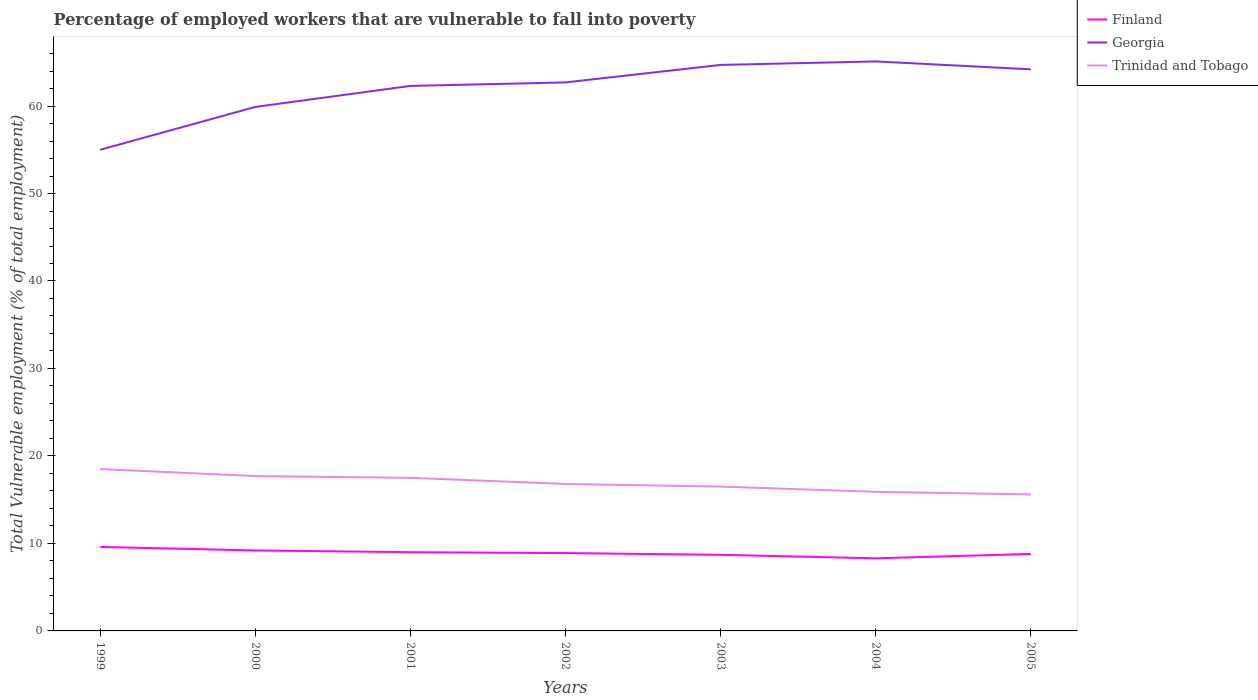How many different coloured lines are there?
Offer a very short reply. 3. Does the line corresponding to Georgia intersect with the line corresponding to Trinidad and Tobago?
Your answer should be very brief. No. Across all years, what is the maximum percentage of employed workers who are vulnerable to fall into poverty in Georgia?
Make the answer very short. 55. In which year was the percentage of employed workers who are vulnerable to fall into poverty in Trinidad and Tobago maximum?
Ensure brevity in your answer.  2005. What is the total percentage of employed workers who are vulnerable to fall into poverty in Trinidad and Tobago in the graph?
Your answer should be very brief. 2.1. What is the difference between the highest and the second highest percentage of employed workers who are vulnerable to fall into poverty in Finland?
Offer a terse response. 1.3. What is the difference between the highest and the lowest percentage of employed workers who are vulnerable to fall into poverty in Trinidad and Tobago?
Offer a very short reply. 3. Is the percentage of employed workers who are vulnerable to fall into poverty in Georgia strictly greater than the percentage of employed workers who are vulnerable to fall into poverty in Finland over the years?
Make the answer very short. No. How many years are there in the graph?
Keep it short and to the point. 7. Where does the legend appear in the graph?
Offer a very short reply. Top right. How many legend labels are there?
Provide a succinct answer. 3. What is the title of the graph?
Provide a short and direct response. Percentage of employed workers that are vulnerable to fall into poverty. Does "Hungary" appear as one of the legend labels in the graph?
Offer a terse response. No. What is the label or title of the Y-axis?
Keep it short and to the point. Total Vulnerable employment (% of total employment). What is the Total Vulnerable employment (% of total employment) of Finland in 1999?
Ensure brevity in your answer.  9.6. What is the Total Vulnerable employment (% of total employment) of Georgia in 1999?
Provide a short and direct response. 55. What is the Total Vulnerable employment (% of total employment) in Trinidad and Tobago in 1999?
Ensure brevity in your answer.  18.5. What is the Total Vulnerable employment (% of total employment) of Finland in 2000?
Offer a very short reply. 9.2. What is the Total Vulnerable employment (% of total employment) of Georgia in 2000?
Offer a very short reply. 59.9. What is the Total Vulnerable employment (% of total employment) of Trinidad and Tobago in 2000?
Offer a very short reply. 17.7. What is the Total Vulnerable employment (% of total employment) of Finland in 2001?
Give a very brief answer. 9. What is the Total Vulnerable employment (% of total employment) of Georgia in 2001?
Offer a very short reply. 62.3. What is the Total Vulnerable employment (% of total employment) in Trinidad and Tobago in 2001?
Your answer should be compact. 17.5. What is the Total Vulnerable employment (% of total employment) in Finland in 2002?
Keep it short and to the point. 8.9. What is the Total Vulnerable employment (% of total employment) of Georgia in 2002?
Ensure brevity in your answer.  62.7. What is the Total Vulnerable employment (% of total employment) in Trinidad and Tobago in 2002?
Provide a short and direct response. 16.8. What is the Total Vulnerable employment (% of total employment) in Finland in 2003?
Your answer should be very brief. 8.7. What is the Total Vulnerable employment (% of total employment) of Georgia in 2003?
Your answer should be very brief. 64.7. What is the Total Vulnerable employment (% of total employment) in Finland in 2004?
Give a very brief answer. 8.3. What is the Total Vulnerable employment (% of total employment) in Georgia in 2004?
Offer a terse response. 65.1. What is the Total Vulnerable employment (% of total employment) in Trinidad and Tobago in 2004?
Give a very brief answer. 15.9. What is the Total Vulnerable employment (% of total employment) of Finland in 2005?
Your response must be concise. 8.8. What is the Total Vulnerable employment (% of total employment) of Georgia in 2005?
Ensure brevity in your answer.  64.2. What is the Total Vulnerable employment (% of total employment) in Trinidad and Tobago in 2005?
Offer a terse response. 15.6. Across all years, what is the maximum Total Vulnerable employment (% of total employment) in Finland?
Your answer should be very brief. 9.6. Across all years, what is the maximum Total Vulnerable employment (% of total employment) in Georgia?
Give a very brief answer. 65.1. Across all years, what is the maximum Total Vulnerable employment (% of total employment) of Trinidad and Tobago?
Your answer should be compact. 18.5. Across all years, what is the minimum Total Vulnerable employment (% of total employment) in Finland?
Make the answer very short. 8.3. Across all years, what is the minimum Total Vulnerable employment (% of total employment) of Georgia?
Your answer should be compact. 55. Across all years, what is the minimum Total Vulnerable employment (% of total employment) of Trinidad and Tobago?
Your response must be concise. 15.6. What is the total Total Vulnerable employment (% of total employment) in Finland in the graph?
Keep it short and to the point. 62.5. What is the total Total Vulnerable employment (% of total employment) of Georgia in the graph?
Make the answer very short. 433.9. What is the total Total Vulnerable employment (% of total employment) in Trinidad and Tobago in the graph?
Ensure brevity in your answer.  118.5. What is the difference between the Total Vulnerable employment (% of total employment) of Georgia in 1999 and that in 2000?
Ensure brevity in your answer.  -4.9. What is the difference between the Total Vulnerable employment (% of total employment) of Georgia in 1999 and that in 2001?
Make the answer very short. -7.3. What is the difference between the Total Vulnerable employment (% of total employment) of Trinidad and Tobago in 1999 and that in 2001?
Provide a succinct answer. 1. What is the difference between the Total Vulnerable employment (% of total employment) in Finland in 1999 and that in 2002?
Your response must be concise. 0.7. What is the difference between the Total Vulnerable employment (% of total employment) in Georgia in 1999 and that in 2002?
Offer a very short reply. -7.7. What is the difference between the Total Vulnerable employment (% of total employment) in Finland in 1999 and that in 2003?
Your answer should be compact. 0.9. What is the difference between the Total Vulnerable employment (% of total employment) of Georgia in 1999 and that in 2003?
Offer a terse response. -9.7. What is the difference between the Total Vulnerable employment (% of total employment) in Finland in 1999 and that in 2004?
Make the answer very short. 1.3. What is the difference between the Total Vulnerable employment (% of total employment) in Finland in 1999 and that in 2005?
Make the answer very short. 0.8. What is the difference between the Total Vulnerable employment (% of total employment) of Georgia in 1999 and that in 2005?
Your answer should be very brief. -9.2. What is the difference between the Total Vulnerable employment (% of total employment) of Finland in 2000 and that in 2001?
Ensure brevity in your answer.  0.2. What is the difference between the Total Vulnerable employment (% of total employment) in Trinidad and Tobago in 2000 and that in 2001?
Ensure brevity in your answer.  0.2. What is the difference between the Total Vulnerable employment (% of total employment) of Finland in 2000 and that in 2002?
Your answer should be very brief. 0.3. What is the difference between the Total Vulnerable employment (% of total employment) in Georgia in 2000 and that in 2002?
Provide a succinct answer. -2.8. What is the difference between the Total Vulnerable employment (% of total employment) in Georgia in 2000 and that in 2003?
Give a very brief answer. -4.8. What is the difference between the Total Vulnerable employment (% of total employment) in Finland in 2000 and that in 2004?
Keep it short and to the point. 0.9. What is the difference between the Total Vulnerable employment (% of total employment) in Georgia in 2000 and that in 2004?
Keep it short and to the point. -5.2. What is the difference between the Total Vulnerable employment (% of total employment) of Trinidad and Tobago in 2000 and that in 2005?
Your answer should be compact. 2.1. What is the difference between the Total Vulnerable employment (% of total employment) of Finland in 2001 and that in 2002?
Keep it short and to the point. 0.1. What is the difference between the Total Vulnerable employment (% of total employment) of Georgia in 2001 and that in 2002?
Your response must be concise. -0.4. What is the difference between the Total Vulnerable employment (% of total employment) in Finland in 2001 and that in 2004?
Give a very brief answer. 0.7. What is the difference between the Total Vulnerable employment (% of total employment) in Georgia in 2001 and that in 2004?
Ensure brevity in your answer.  -2.8. What is the difference between the Total Vulnerable employment (% of total employment) in Trinidad and Tobago in 2001 and that in 2004?
Give a very brief answer. 1.6. What is the difference between the Total Vulnerable employment (% of total employment) in Georgia in 2001 and that in 2005?
Make the answer very short. -1.9. What is the difference between the Total Vulnerable employment (% of total employment) of Finland in 2002 and that in 2003?
Make the answer very short. 0.2. What is the difference between the Total Vulnerable employment (% of total employment) in Georgia in 2002 and that in 2003?
Your response must be concise. -2. What is the difference between the Total Vulnerable employment (% of total employment) in Georgia in 2002 and that in 2004?
Give a very brief answer. -2.4. What is the difference between the Total Vulnerable employment (% of total employment) in Finland in 2002 and that in 2005?
Offer a very short reply. 0.1. What is the difference between the Total Vulnerable employment (% of total employment) in Trinidad and Tobago in 2002 and that in 2005?
Keep it short and to the point. 1.2. What is the difference between the Total Vulnerable employment (% of total employment) of Finland in 2003 and that in 2004?
Offer a very short reply. 0.4. What is the difference between the Total Vulnerable employment (% of total employment) of Georgia in 2003 and that in 2004?
Your answer should be compact. -0.4. What is the difference between the Total Vulnerable employment (% of total employment) of Finland in 2004 and that in 2005?
Offer a terse response. -0.5. What is the difference between the Total Vulnerable employment (% of total employment) of Finland in 1999 and the Total Vulnerable employment (% of total employment) of Georgia in 2000?
Offer a terse response. -50.3. What is the difference between the Total Vulnerable employment (% of total employment) of Georgia in 1999 and the Total Vulnerable employment (% of total employment) of Trinidad and Tobago in 2000?
Give a very brief answer. 37.3. What is the difference between the Total Vulnerable employment (% of total employment) in Finland in 1999 and the Total Vulnerable employment (% of total employment) in Georgia in 2001?
Keep it short and to the point. -52.7. What is the difference between the Total Vulnerable employment (% of total employment) in Georgia in 1999 and the Total Vulnerable employment (% of total employment) in Trinidad and Tobago in 2001?
Your response must be concise. 37.5. What is the difference between the Total Vulnerable employment (% of total employment) of Finland in 1999 and the Total Vulnerable employment (% of total employment) of Georgia in 2002?
Your answer should be very brief. -53.1. What is the difference between the Total Vulnerable employment (% of total employment) in Finland in 1999 and the Total Vulnerable employment (% of total employment) in Trinidad and Tobago in 2002?
Your answer should be very brief. -7.2. What is the difference between the Total Vulnerable employment (% of total employment) of Georgia in 1999 and the Total Vulnerable employment (% of total employment) of Trinidad and Tobago in 2002?
Your answer should be compact. 38.2. What is the difference between the Total Vulnerable employment (% of total employment) in Finland in 1999 and the Total Vulnerable employment (% of total employment) in Georgia in 2003?
Offer a very short reply. -55.1. What is the difference between the Total Vulnerable employment (% of total employment) in Finland in 1999 and the Total Vulnerable employment (% of total employment) in Trinidad and Tobago in 2003?
Give a very brief answer. -6.9. What is the difference between the Total Vulnerable employment (% of total employment) of Georgia in 1999 and the Total Vulnerable employment (% of total employment) of Trinidad and Tobago in 2003?
Offer a very short reply. 38.5. What is the difference between the Total Vulnerable employment (% of total employment) in Finland in 1999 and the Total Vulnerable employment (% of total employment) in Georgia in 2004?
Make the answer very short. -55.5. What is the difference between the Total Vulnerable employment (% of total employment) in Georgia in 1999 and the Total Vulnerable employment (% of total employment) in Trinidad and Tobago in 2004?
Keep it short and to the point. 39.1. What is the difference between the Total Vulnerable employment (% of total employment) of Finland in 1999 and the Total Vulnerable employment (% of total employment) of Georgia in 2005?
Provide a short and direct response. -54.6. What is the difference between the Total Vulnerable employment (% of total employment) in Georgia in 1999 and the Total Vulnerable employment (% of total employment) in Trinidad and Tobago in 2005?
Provide a short and direct response. 39.4. What is the difference between the Total Vulnerable employment (% of total employment) in Finland in 2000 and the Total Vulnerable employment (% of total employment) in Georgia in 2001?
Ensure brevity in your answer.  -53.1. What is the difference between the Total Vulnerable employment (% of total employment) in Georgia in 2000 and the Total Vulnerable employment (% of total employment) in Trinidad and Tobago in 2001?
Offer a terse response. 42.4. What is the difference between the Total Vulnerable employment (% of total employment) of Finland in 2000 and the Total Vulnerable employment (% of total employment) of Georgia in 2002?
Your answer should be very brief. -53.5. What is the difference between the Total Vulnerable employment (% of total employment) in Georgia in 2000 and the Total Vulnerable employment (% of total employment) in Trinidad and Tobago in 2002?
Your answer should be very brief. 43.1. What is the difference between the Total Vulnerable employment (% of total employment) in Finland in 2000 and the Total Vulnerable employment (% of total employment) in Georgia in 2003?
Provide a short and direct response. -55.5. What is the difference between the Total Vulnerable employment (% of total employment) of Georgia in 2000 and the Total Vulnerable employment (% of total employment) of Trinidad and Tobago in 2003?
Give a very brief answer. 43.4. What is the difference between the Total Vulnerable employment (% of total employment) in Finland in 2000 and the Total Vulnerable employment (% of total employment) in Georgia in 2004?
Your answer should be compact. -55.9. What is the difference between the Total Vulnerable employment (% of total employment) of Finland in 2000 and the Total Vulnerable employment (% of total employment) of Trinidad and Tobago in 2004?
Ensure brevity in your answer.  -6.7. What is the difference between the Total Vulnerable employment (% of total employment) in Finland in 2000 and the Total Vulnerable employment (% of total employment) in Georgia in 2005?
Your answer should be very brief. -55. What is the difference between the Total Vulnerable employment (% of total employment) in Georgia in 2000 and the Total Vulnerable employment (% of total employment) in Trinidad and Tobago in 2005?
Your answer should be very brief. 44.3. What is the difference between the Total Vulnerable employment (% of total employment) of Finland in 2001 and the Total Vulnerable employment (% of total employment) of Georgia in 2002?
Keep it short and to the point. -53.7. What is the difference between the Total Vulnerable employment (% of total employment) in Georgia in 2001 and the Total Vulnerable employment (% of total employment) in Trinidad and Tobago in 2002?
Offer a very short reply. 45.5. What is the difference between the Total Vulnerable employment (% of total employment) in Finland in 2001 and the Total Vulnerable employment (% of total employment) in Georgia in 2003?
Keep it short and to the point. -55.7. What is the difference between the Total Vulnerable employment (% of total employment) in Finland in 2001 and the Total Vulnerable employment (% of total employment) in Trinidad and Tobago in 2003?
Your answer should be compact. -7.5. What is the difference between the Total Vulnerable employment (% of total employment) of Georgia in 2001 and the Total Vulnerable employment (% of total employment) of Trinidad and Tobago in 2003?
Offer a very short reply. 45.8. What is the difference between the Total Vulnerable employment (% of total employment) of Finland in 2001 and the Total Vulnerable employment (% of total employment) of Georgia in 2004?
Keep it short and to the point. -56.1. What is the difference between the Total Vulnerable employment (% of total employment) in Georgia in 2001 and the Total Vulnerable employment (% of total employment) in Trinidad and Tobago in 2004?
Offer a very short reply. 46.4. What is the difference between the Total Vulnerable employment (% of total employment) of Finland in 2001 and the Total Vulnerable employment (% of total employment) of Georgia in 2005?
Your answer should be very brief. -55.2. What is the difference between the Total Vulnerable employment (% of total employment) in Georgia in 2001 and the Total Vulnerable employment (% of total employment) in Trinidad and Tobago in 2005?
Provide a succinct answer. 46.7. What is the difference between the Total Vulnerable employment (% of total employment) in Finland in 2002 and the Total Vulnerable employment (% of total employment) in Georgia in 2003?
Provide a succinct answer. -55.8. What is the difference between the Total Vulnerable employment (% of total employment) of Georgia in 2002 and the Total Vulnerable employment (% of total employment) of Trinidad and Tobago in 2003?
Your response must be concise. 46.2. What is the difference between the Total Vulnerable employment (% of total employment) in Finland in 2002 and the Total Vulnerable employment (% of total employment) in Georgia in 2004?
Your response must be concise. -56.2. What is the difference between the Total Vulnerable employment (% of total employment) in Finland in 2002 and the Total Vulnerable employment (% of total employment) in Trinidad and Tobago in 2004?
Offer a terse response. -7. What is the difference between the Total Vulnerable employment (% of total employment) of Georgia in 2002 and the Total Vulnerable employment (% of total employment) of Trinidad and Tobago in 2004?
Offer a terse response. 46.8. What is the difference between the Total Vulnerable employment (% of total employment) of Finland in 2002 and the Total Vulnerable employment (% of total employment) of Georgia in 2005?
Provide a succinct answer. -55.3. What is the difference between the Total Vulnerable employment (% of total employment) of Georgia in 2002 and the Total Vulnerable employment (% of total employment) of Trinidad and Tobago in 2005?
Keep it short and to the point. 47.1. What is the difference between the Total Vulnerable employment (% of total employment) of Finland in 2003 and the Total Vulnerable employment (% of total employment) of Georgia in 2004?
Provide a succinct answer. -56.4. What is the difference between the Total Vulnerable employment (% of total employment) in Georgia in 2003 and the Total Vulnerable employment (% of total employment) in Trinidad and Tobago in 2004?
Ensure brevity in your answer.  48.8. What is the difference between the Total Vulnerable employment (% of total employment) in Finland in 2003 and the Total Vulnerable employment (% of total employment) in Georgia in 2005?
Provide a short and direct response. -55.5. What is the difference between the Total Vulnerable employment (% of total employment) of Georgia in 2003 and the Total Vulnerable employment (% of total employment) of Trinidad and Tobago in 2005?
Ensure brevity in your answer.  49.1. What is the difference between the Total Vulnerable employment (% of total employment) in Finland in 2004 and the Total Vulnerable employment (% of total employment) in Georgia in 2005?
Make the answer very short. -55.9. What is the difference between the Total Vulnerable employment (% of total employment) of Finland in 2004 and the Total Vulnerable employment (% of total employment) of Trinidad and Tobago in 2005?
Ensure brevity in your answer.  -7.3. What is the difference between the Total Vulnerable employment (% of total employment) in Georgia in 2004 and the Total Vulnerable employment (% of total employment) in Trinidad and Tobago in 2005?
Make the answer very short. 49.5. What is the average Total Vulnerable employment (% of total employment) of Finland per year?
Provide a short and direct response. 8.93. What is the average Total Vulnerable employment (% of total employment) in Georgia per year?
Provide a short and direct response. 61.99. What is the average Total Vulnerable employment (% of total employment) of Trinidad and Tobago per year?
Provide a short and direct response. 16.93. In the year 1999, what is the difference between the Total Vulnerable employment (% of total employment) in Finland and Total Vulnerable employment (% of total employment) in Georgia?
Your answer should be compact. -45.4. In the year 1999, what is the difference between the Total Vulnerable employment (% of total employment) of Georgia and Total Vulnerable employment (% of total employment) of Trinidad and Tobago?
Your answer should be compact. 36.5. In the year 2000, what is the difference between the Total Vulnerable employment (% of total employment) of Finland and Total Vulnerable employment (% of total employment) of Georgia?
Ensure brevity in your answer.  -50.7. In the year 2000, what is the difference between the Total Vulnerable employment (% of total employment) in Georgia and Total Vulnerable employment (% of total employment) in Trinidad and Tobago?
Ensure brevity in your answer.  42.2. In the year 2001, what is the difference between the Total Vulnerable employment (% of total employment) of Finland and Total Vulnerable employment (% of total employment) of Georgia?
Your answer should be compact. -53.3. In the year 2001, what is the difference between the Total Vulnerable employment (% of total employment) in Georgia and Total Vulnerable employment (% of total employment) in Trinidad and Tobago?
Your answer should be compact. 44.8. In the year 2002, what is the difference between the Total Vulnerable employment (% of total employment) in Finland and Total Vulnerable employment (% of total employment) in Georgia?
Provide a succinct answer. -53.8. In the year 2002, what is the difference between the Total Vulnerable employment (% of total employment) in Georgia and Total Vulnerable employment (% of total employment) in Trinidad and Tobago?
Provide a succinct answer. 45.9. In the year 2003, what is the difference between the Total Vulnerable employment (% of total employment) in Finland and Total Vulnerable employment (% of total employment) in Georgia?
Give a very brief answer. -56. In the year 2003, what is the difference between the Total Vulnerable employment (% of total employment) in Finland and Total Vulnerable employment (% of total employment) in Trinidad and Tobago?
Keep it short and to the point. -7.8. In the year 2003, what is the difference between the Total Vulnerable employment (% of total employment) in Georgia and Total Vulnerable employment (% of total employment) in Trinidad and Tobago?
Ensure brevity in your answer.  48.2. In the year 2004, what is the difference between the Total Vulnerable employment (% of total employment) of Finland and Total Vulnerable employment (% of total employment) of Georgia?
Offer a very short reply. -56.8. In the year 2004, what is the difference between the Total Vulnerable employment (% of total employment) in Georgia and Total Vulnerable employment (% of total employment) in Trinidad and Tobago?
Offer a terse response. 49.2. In the year 2005, what is the difference between the Total Vulnerable employment (% of total employment) in Finland and Total Vulnerable employment (% of total employment) in Georgia?
Give a very brief answer. -55.4. In the year 2005, what is the difference between the Total Vulnerable employment (% of total employment) in Finland and Total Vulnerable employment (% of total employment) in Trinidad and Tobago?
Give a very brief answer. -6.8. In the year 2005, what is the difference between the Total Vulnerable employment (% of total employment) in Georgia and Total Vulnerable employment (% of total employment) in Trinidad and Tobago?
Ensure brevity in your answer.  48.6. What is the ratio of the Total Vulnerable employment (% of total employment) in Finland in 1999 to that in 2000?
Provide a succinct answer. 1.04. What is the ratio of the Total Vulnerable employment (% of total employment) in Georgia in 1999 to that in 2000?
Provide a succinct answer. 0.92. What is the ratio of the Total Vulnerable employment (% of total employment) in Trinidad and Tobago in 1999 to that in 2000?
Offer a very short reply. 1.05. What is the ratio of the Total Vulnerable employment (% of total employment) of Finland in 1999 to that in 2001?
Offer a terse response. 1.07. What is the ratio of the Total Vulnerable employment (% of total employment) of Georgia in 1999 to that in 2001?
Ensure brevity in your answer.  0.88. What is the ratio of the Total Vulnerable employment (% of total employment) in Trinidad and Tobago in 1999 to that in 2001?
Offer a terse response. 1.06. What is the ratio of the Total Vulnerable employment (% of total employment) in Finland in 1999 to that in 2002?
Provide a short and direct response. 1.08. What is the ratio of the Total Vulnerable employment (% of total employment) in Georgia in 1999 to that in 2002?
Your response must be concise. 0.88. What is the ratio of the Total Vulnerable employment (% of total employment) in Trinidad and Tobago in 1999 to that in 2002?
Provide a succinct answer. 1.1. What is the ratio of the Total Vulnerable employment (% of total employment) of Finland in 1999 to that in 2003?
Give a very brief answer. 1.1. What is the ratio of the Total Vulnerable employment (% of total employment) in Georgia in 1999 to that in 2003?
Give a very brief answer. 0.85. What is the ratio of the Total Vulnerable employment (% of total employment) in Trinidad and Tobago in 1999 to that in 2003?
Your answer should be very brief. 1.12. What is the ratio of the Total Vulnerable employment (% of total employment) in Finland in 1999 to that in 2004?
Provide a succinct answer. 1.16. What is the ratio of the Total Vulnerable employment (% of total employment) in Georgia in 1999 to that in 2004?
Provide a short and direct response. 0.84. What is the ratio of the Total Vulnerable employment (% of total employment) in Trinidad and Tobago in 1999 to that in 2004?
Keep it short and to the point. 1.16. What is the ratio of the Total Vulnerable employment (% of total employment) of Finland in 1999 to that in 2005?
Provide a short and direct response. 1.09. What is the ratio of the Total Vulnerable employment (% of total employment) in Georgia in 1999 to that in 2005?
Your answer should be very brief. 0.86. What is the ratio of the Total Vulnerable employment (% of total employment) in Trinidad and Tobago in 1999 to that in 2005?
Your response must be concise. 1.19. What is the ratio of the Total Vulnerable employment (% of total employment) of Finland in 2000 to that in 2001?
Provide a succinct answer. 1.02. What is the ratio of the Total Vulnerable employment (% of total employment) of Georgia in 2000 to that in 2001?
Make the answer very short. 0.96. What is the ratio of the Total Vulnerable employment (% of total employment) of Trinidad and Tobago in 2000 to that in 2001?
Provide a short and direct response. 1.01. What is the ratio of the Total Vulnerable employment (% of total employment) of Finland in 2000 to that in 2002?
Keep it short and to the point. 1.03. What is the ratio of the Total Vulnerable employment (% of total employment) in Georgia in 2000 to that in 2002?
Offer a terse response. 0.96. What is the ratio of the Total Vulnerable employment (% of total employment) in Trinidad and Tobago in 2000 to that in 2002?
Ensure brevity in your answer.  1.05. What is the ratio of the Total Vulnerable employment (% of total employment) of Finland in 2000 to that in 2003?
Make the answer very short. 1.06. What is the ratio of the Total Vulnerable employment (% of total employment) of Georgia in 2000 to that in 2003?
Ensure brevity in your answer.  0.93. What is the ratio of the Total Vulnerable employment (% of total employment) in Trinidad and Tobago in 2000 to that in 2003?
Offer a very short reply. 1.07. What is the ratio of the Total Vulnerable employment (% of total employment) of Finland in 2000 to that in 2004?
Offer a terse response. 1.11. What is the ratio of the Total Vulnerable employment (% of total employment) in Georgia in 2000 to that in 2004?
Give a very brief answer. 0.92. What is the ratio of the Total Vulnerable employment (% of total employment) of Trinidad and Tobago in 2000 to that in 2004?
Keep it short and to the point. 1.11. What is the ratio of the Total Vulnerable employment (% of total employment) in Finland in 2000 to that in 2005?
Your answer should be very brief. 1.05. What is the ratio of the Total Vulnerable employment (% of total employment) in Georgia in 2000 to that in 2005?
Your answer should be very brief. 0.93. What is the ratio of the Total Vulnerable employment (% of total employment) in Trinidad and Tobago in 2000 to that in 2005?
Provide a short and direct response. 1.13. What is the ratio of the Total Vulnerable employment (% of total employment) in Finland in 2001 to that in 2002?
Give a very brief answer. 1.01. What is the ratio of the Total Vulnerable employment (% of total employment) of Trinidad and Tobago in 2001 to that in 2002?
Offer a very short reply. 1.04. What is the ratio of the Total Vulnerable employment (% of total employment) in Finland in 2001 to that in 2003?
Offer a terse response. 1.03. What is the ratio of the Total Vulnerable employment (% of total employment) in Georgia in 2001 to that in 2003?
Your response must be concise. 0.96. What is the ratio of the Total Vulnerable employment (% of total employment) in Trinidad and Tobago in 2001 to that in 2003?
Make the answer very short. 1.06. What is the ratio of the Total Vulnerable employment (% of total employment) of Finland in 2001 to that in 2004?
Provide a short and direct response. 1.08. What is the ratio of the Total Vulnerable employment (% of total employment) in Trinidad and Tobago in 2001 to that in 2004?
Your answer should be compact. 1.1. What is the ratio of the Total Vulnerable employment (% of total employment) of Finland in 2001 to that in 2005?
Make the answer very short. 1.02. What is the ratio of the Total Vulnerable employment (% of total employment) of Georgia in 2001 to that in 2005?
Give a very brief answer. 0.97. What is the ratio of the Total Vulnerable employment (% of total employment) of Trinidad and Tobago in 2001 to that in 2005?
Keep it short and to the point. 1.12. What is the ratio of the Total Vulnerable employment (% of total employment) of Georgia in 2002 to that in 2003?
Keep it short and to the point. 0.97. What is the ratio of the Total Vulnerable employment (% of total employment) of Trinidad and Tobago in 2002 to that in 2003?
Keep it short and to the point. 1.02. What is the ratio of the Total Vulnerable employment (% of total employment) of Finland in 2002 to that in 2004?
Provide a succinct answer. 1.07. What is the ratio of the Total Vulnerable employment (% of total employment) of Georgia in 2002 to that in 2004?
Provide a short and direct response. 0.96. What is the ratio of the Total Vulnerable employment (% of total employment) in Trinidad and Tobago in 2002 to that in 2004?
Give a very brief answer. 1.06. What is the ratio of the Total Vulnerable employment (% of total employment) of Finland in 2002 to that in 2005?
Keep it short and to the point. 1.01. What is the ratio of the Total Vulnerable employment (% of total employment) of Georgia in 2002 to that in 2005?
Provide a short and direct response. 0.98. What is the ratio of the Total Vulnerable employment (% of total employment) of Finland in 2003 to that in 2004?
Provide a short and direct response. 1.05. What is the ratio of the Total Vulnerable employment (% of total employment) in Georgia in 2003 to that in 2004?
Make the answer very short. 0.99. What is the ratio of the Total Vulnerable employment (% of total employment) of Trinidad and Tobago in 2003 to that in 2004?
Offer a very short reply. 1.04. What is the ratio of the Total Vulnerable employment (% of total employment) of Georgia in 2003 to that in 2005?
Keep it short and to the point. 1.01. What is the ratio of the Total Vulnerable employment (% of total employment) of Trinidad and Tobago in 2003 to that in 2005?
Keep it short and to the point. 1.06. What is the ratio of the Total Vulnerable employment (% of total employment) of Finland in 2004 to that in 2005?
Your answer should be compact. 0.94. What is the ratio of the Total Vulnerable employment (% of total employment) of Georgia in 2004 to that in 2005?
Keep it short and to the point. 1.01. What is the ratio of the Total Vulnerable employment (% of total employment) in Trinidad and Tobago in 2004 to that in 2005?
Ensure brevity in your answer.  1.02. What is the difference between the highest and the second highest Total Vulnerable employment (% of total employment) in Finland?
Ensure brevity in your answer.  0.4. What is the difference between the highest and the second highest Total Vulnerable employment (% of total employment) in Trinidad and Tobago?
Your response must be concise. 0.8. What is the difference between the highest and the lowest Total Vulnerable employment (% of total employment) of Georgia?
Your response must be concise. 10.1. What is the difference between the highest and the lowest Total Vulnerable employment (% of total employment) in Trinidad and Tobago?
Offer a terse response. 2.9. 